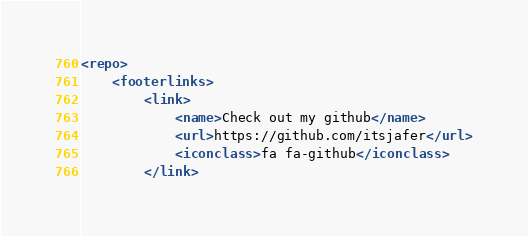Convert code to text. <code><loc_0><loc_0><loc_500><loc_500><_XML_><repo>
	<footerlinks>
		<link>
			<name>Check out my github</name>
			<url>https://github.com/itsjafer</url>
			<iconclass>fa fa-github</iconclass>
		</link></code> 